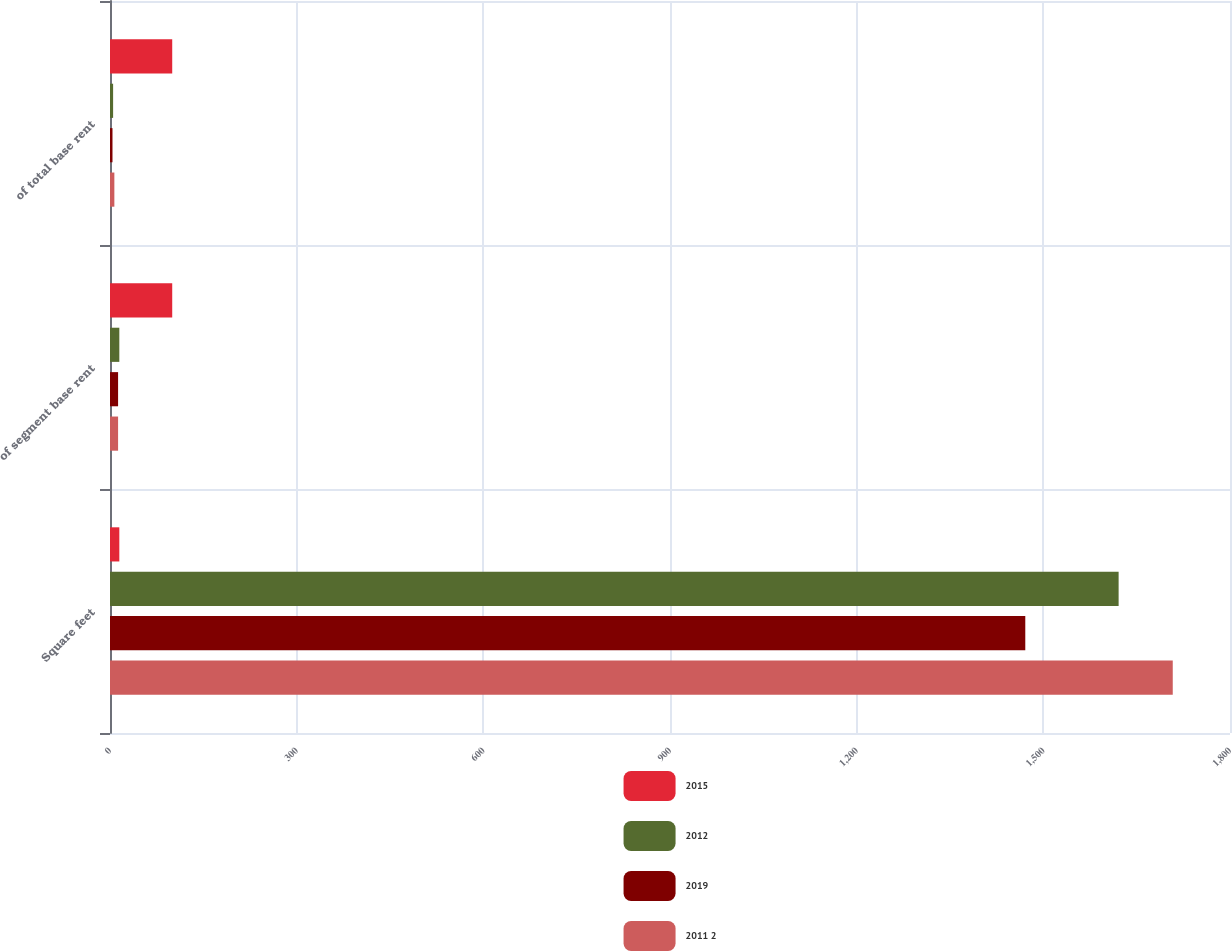Convert chart. <chart><loc_0><loc_0><loc_500><loc_500><stacked_bar_chart><ecel><fcel>Square feet<fcel>of segment base rent<fcel>of total base rent<nl><fcel>2015<fcel>15<fcel>100<fcel>100<nl><fcel>2012<fcel>1621<fcel>15<fcel>5<nl><fcel>2019<fcel>1471<fcel>13<fcel>4<nl><fcel>2011 2<fcel>1708<fcel>13<fcel>7<nl></chart> 